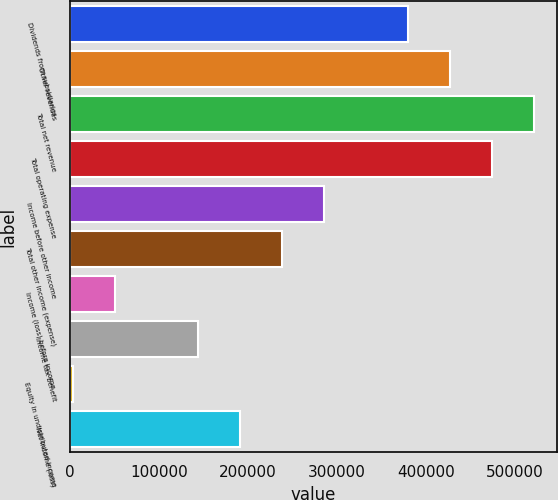<chart> <loc_0><loc_0><loc_500><loc_500><bar_chart><fcel>Dividends from subsidiaries<fcel>Other revenues<fcel>Total net revenue<fcel>Total operating expense<fcel>Income before other income<fcel>Total other income (expense)<fcel>Income (loss) before income<fcel>Income tax benefit<fcel>Equity in undistributed income<fcel>Net income (loss)<nl><fcel>380052<fcel>427147<fcel>521337<fcel>474242<fcel>285862<fcel>238768<fcel>50387.9<fcel>144578<fcel>3293<fcel>191673<nl></chart> 